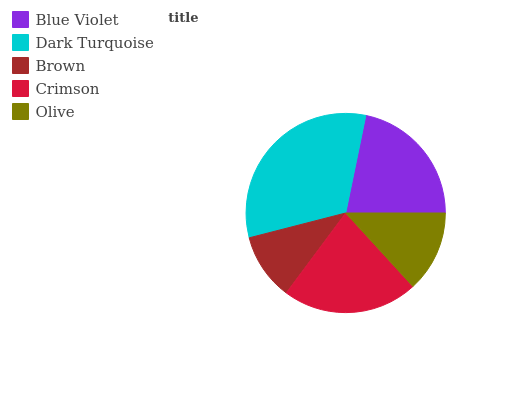Is Brown the minimum?
Answer yes or no. Yes. Is Dark Turquoise the maximum?
Answer yes or no. Yes. Is Dark Turquoise the minimum?
Answer yes or no. No. Is Brown the maximum?
Answer yes or no. No. Is Dark Turquoise greater than Brown?
Answer yes or no. Yes. Is Brown less than Dark Turquoise?
Answer yes or no. Yes. Is Brown greater than Dark Turquoise?
Answer yes or no. No. Is Dark Turquoise less than Brown?
Answer yes or no. No. Is Blue Violet the high median?
Answer yes or no. Yes. Is Blue Violet the low median?
Answer yes or no. Yes. Is Brown the high median?
Answer yes or no. No. Is Brown the low median?
Answer yes or no. No. 